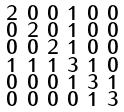Convert formula to latex. <formula><loc_0><loc_0><loc_500><loc_500>\begin{smallmatrix} 2 & 0 & 0 & 1 & 0 & 0 \\ 0 & 2 & 0 & 1 & 0 & 0 \\ 0 & 0 & 2 & 1 & 0 & 0 \\ 1 & 1 & 1 & 3 & 1 & 0 \\ 0 & 0 & 0 & 1 & 3 & 1 \\ 0 & 0 & 0 & 0 & 1 & 3 \end{smallmatrix}</formula> 